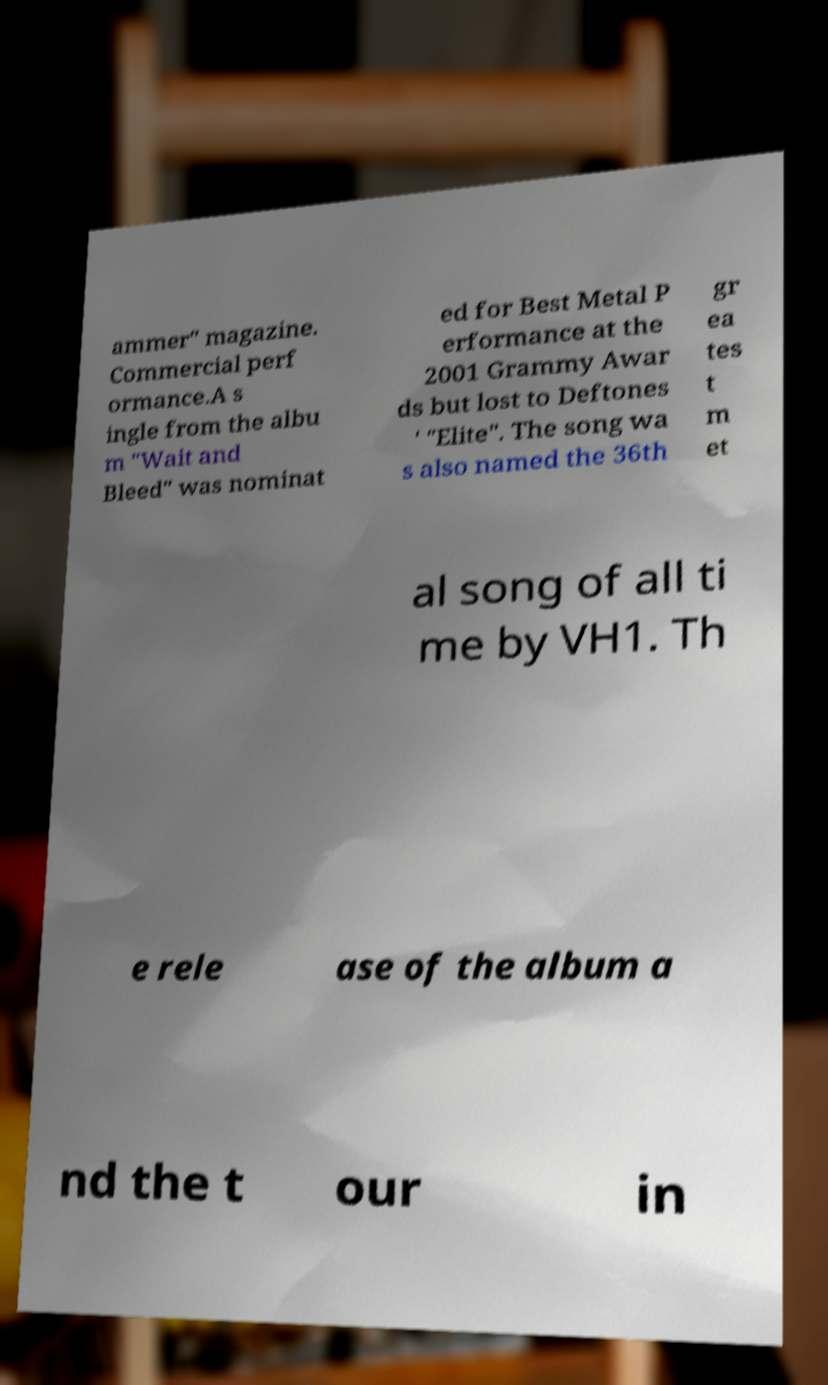Could you extract and type out the text from this image? ammer" magazine. Commercial perf ormance.A s ingle from the albu m "Wait and Bleed" was nominat ed for Best Metal P erformance at the 2001 Grammy Awar ds but lost to Deftones ' "Elite". The song wa s also named the 36th gr ea tes t m et al song of all ti me by VH1. Th e rele ase of the album a nd the t our in 